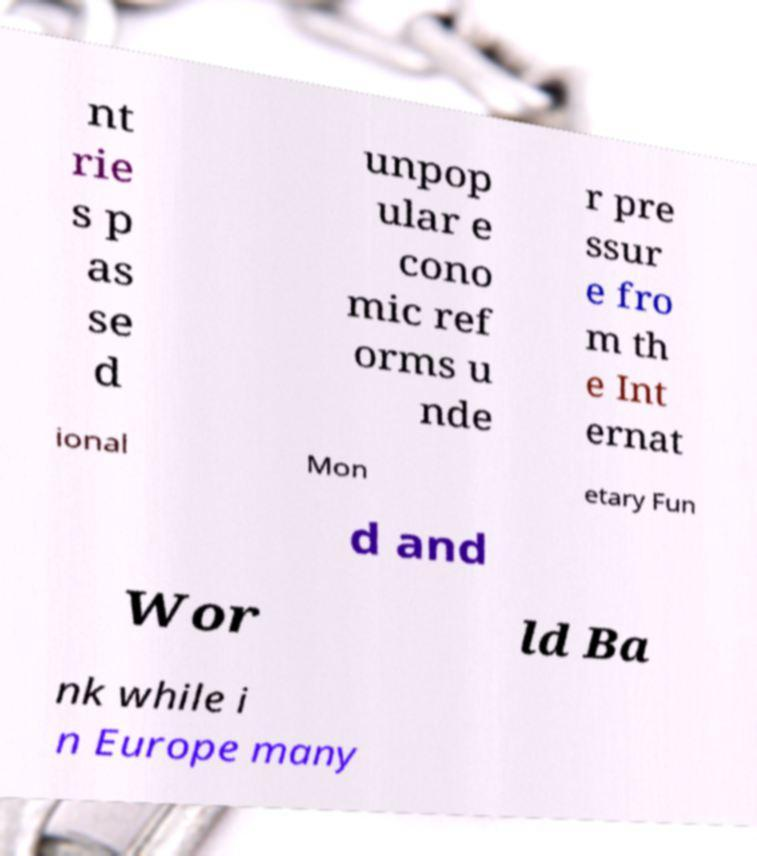For documentation purposes, I need the text within this image transcribed. Could you provide that? nt rie s p as se d unpop ular e cono mic ref orms u nde r pre ssur e fro m th e Int ernat ional Mon etary Fun d and Wor ld Ba nk while i n Europe many 